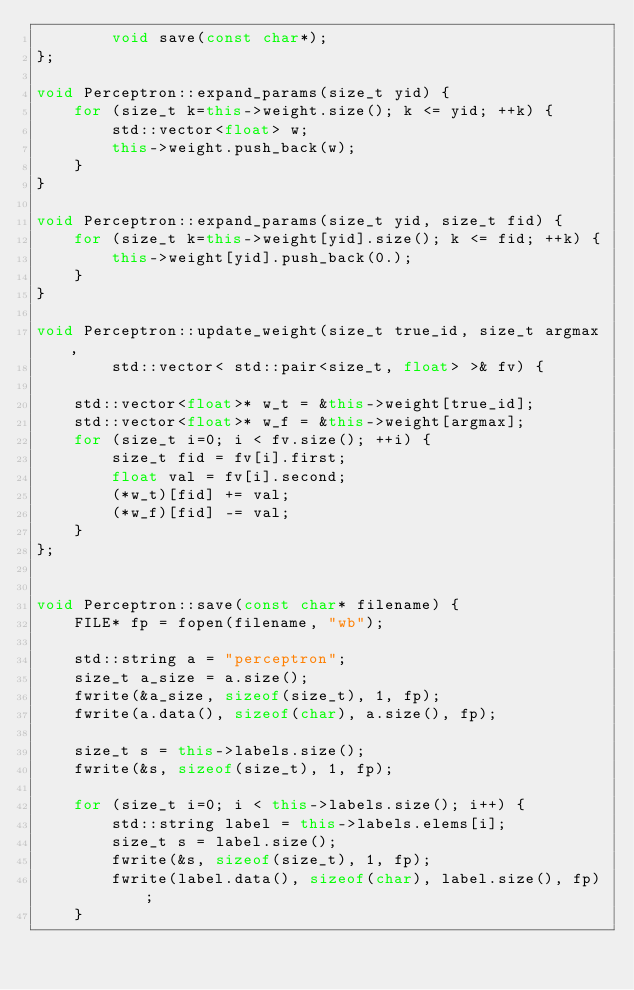<code> <loc_0><loc_0><loc_500><loc_500><_C++_>        void save(const char*);
};

void Perceptron::expand_params(size_t yid) {
    for (size_t k=this->weight.size(); k <= yid; ++k) {
        std::vector<float> w;
        this->weight.push_back(w);
    }
}

void Perceptron::expand_params(size_t yid, size_t fid) {
    for (size_t k=this->weight[yid].size(); k <= fid; ++k) {
        this->weight[yid].push_back(0.);
    }
}

void Perceptron::update_weight(size_t true_id, size_t argmax,
        std::vector< std::pair<size_t, float> >& fv) {

    std::vector<float>* w_t = &this->weight[true_id];
    std::vector<float>* w_f = &this->weight[argmax];
    for (size_t i=0; i < fv.size(); ++i) {
        size_t fid = fv[i].first;
        float val = fv[i].second;
        (*w_t)[fid] += val;
        (*w_f)[fid] -= val;
    }
};


void Perceptron::save(const char* filename) {
    FILE* fp = fopen(filename, "wb");

    std::string a = "perceptron";
    size_t a_size = a.size();
    fwrite(&a_size, sizeof(size_t), 1, fp);
    fwrite(a.data(), sizeof(char), a.size(), fp);

    size_t s = this->labels.size();
    fwrite(&s, sizeof(size_t), 1, fp);

    for (size_t i=0; i < this->labels.size(); i++) {
        std::string label = this->labels.elems[i];
        size_t s = label.size();
        fwrite(&s, sizeof(size_t), 1, fp);
        fwrite(label.data(), sizeof(char), label.size(), fp);
    }
</code> 